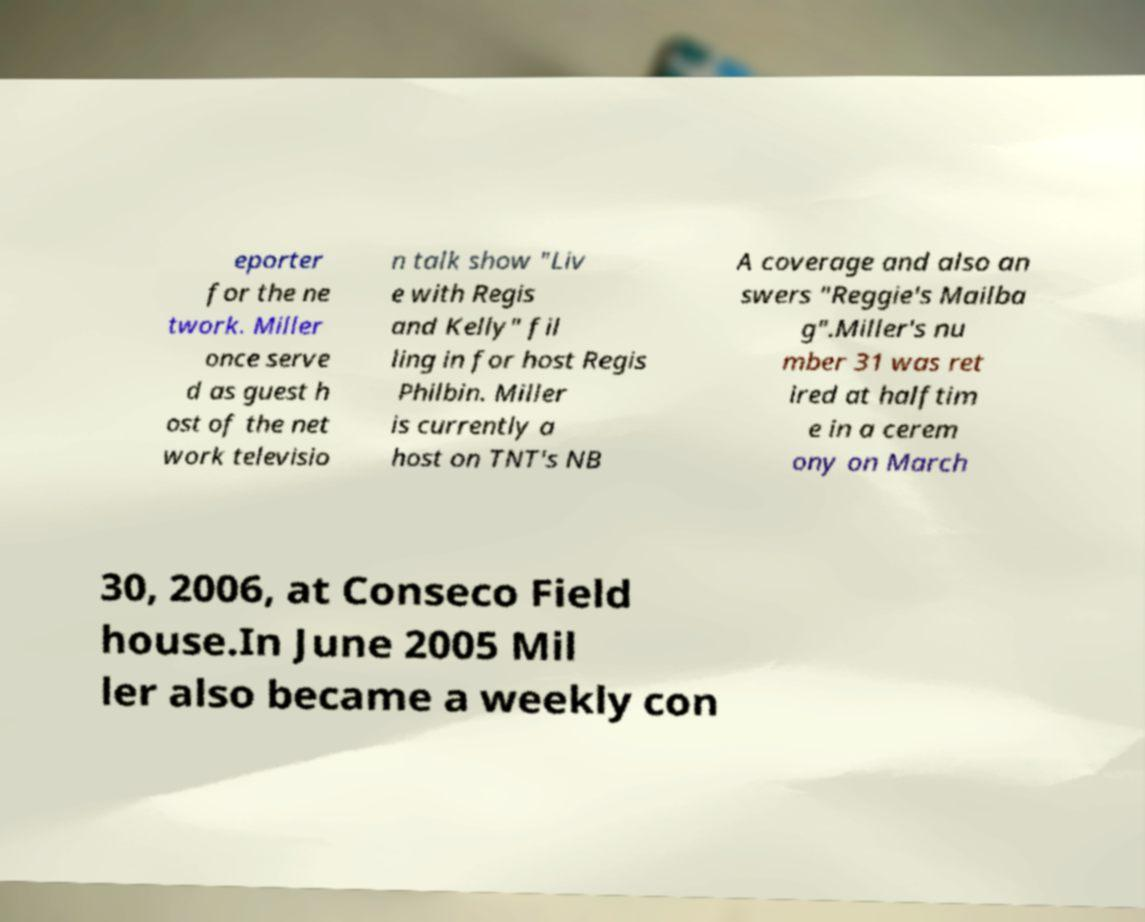Could you assist in decoding the text presented in this image and type it out clearly? eporter for the ne twork. Miller once serve d as guest h ost of the net work televisio n talk show "Liv e with Regis and Kelly" fil ling in for host Regis Philbin. Miller is currently a host on TNT's NB A coverage and also an swers "Reggie's Mailba g".Miller's nu mber 31 was ret ired at halftim e in a cerem ony on March 30, 2006, at Conseco Field house.In June 2005 Mil ler also became a weekly con 